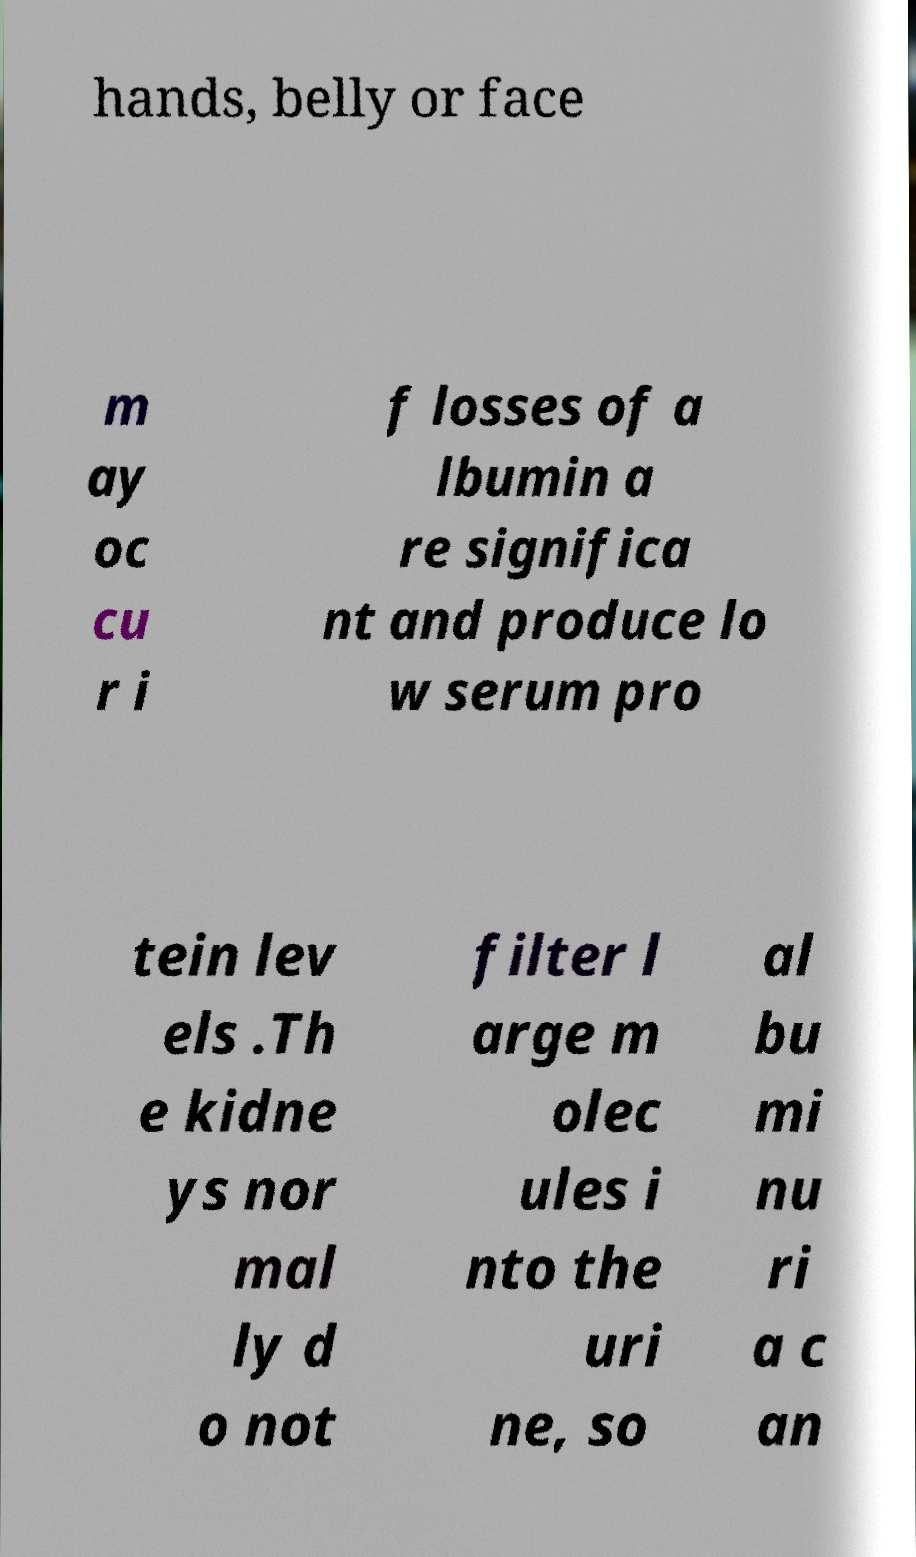Could you extract and type out the text from this image? hands, belly or face m ay oc cu r i f losses of a lbumin a re significa nt and produce lo w serum pro tein lev els .Th e kidne ys nor mal ly d o not filter l arge m olec ules i nto the uri ne, so al bu mi nu ri a c an 